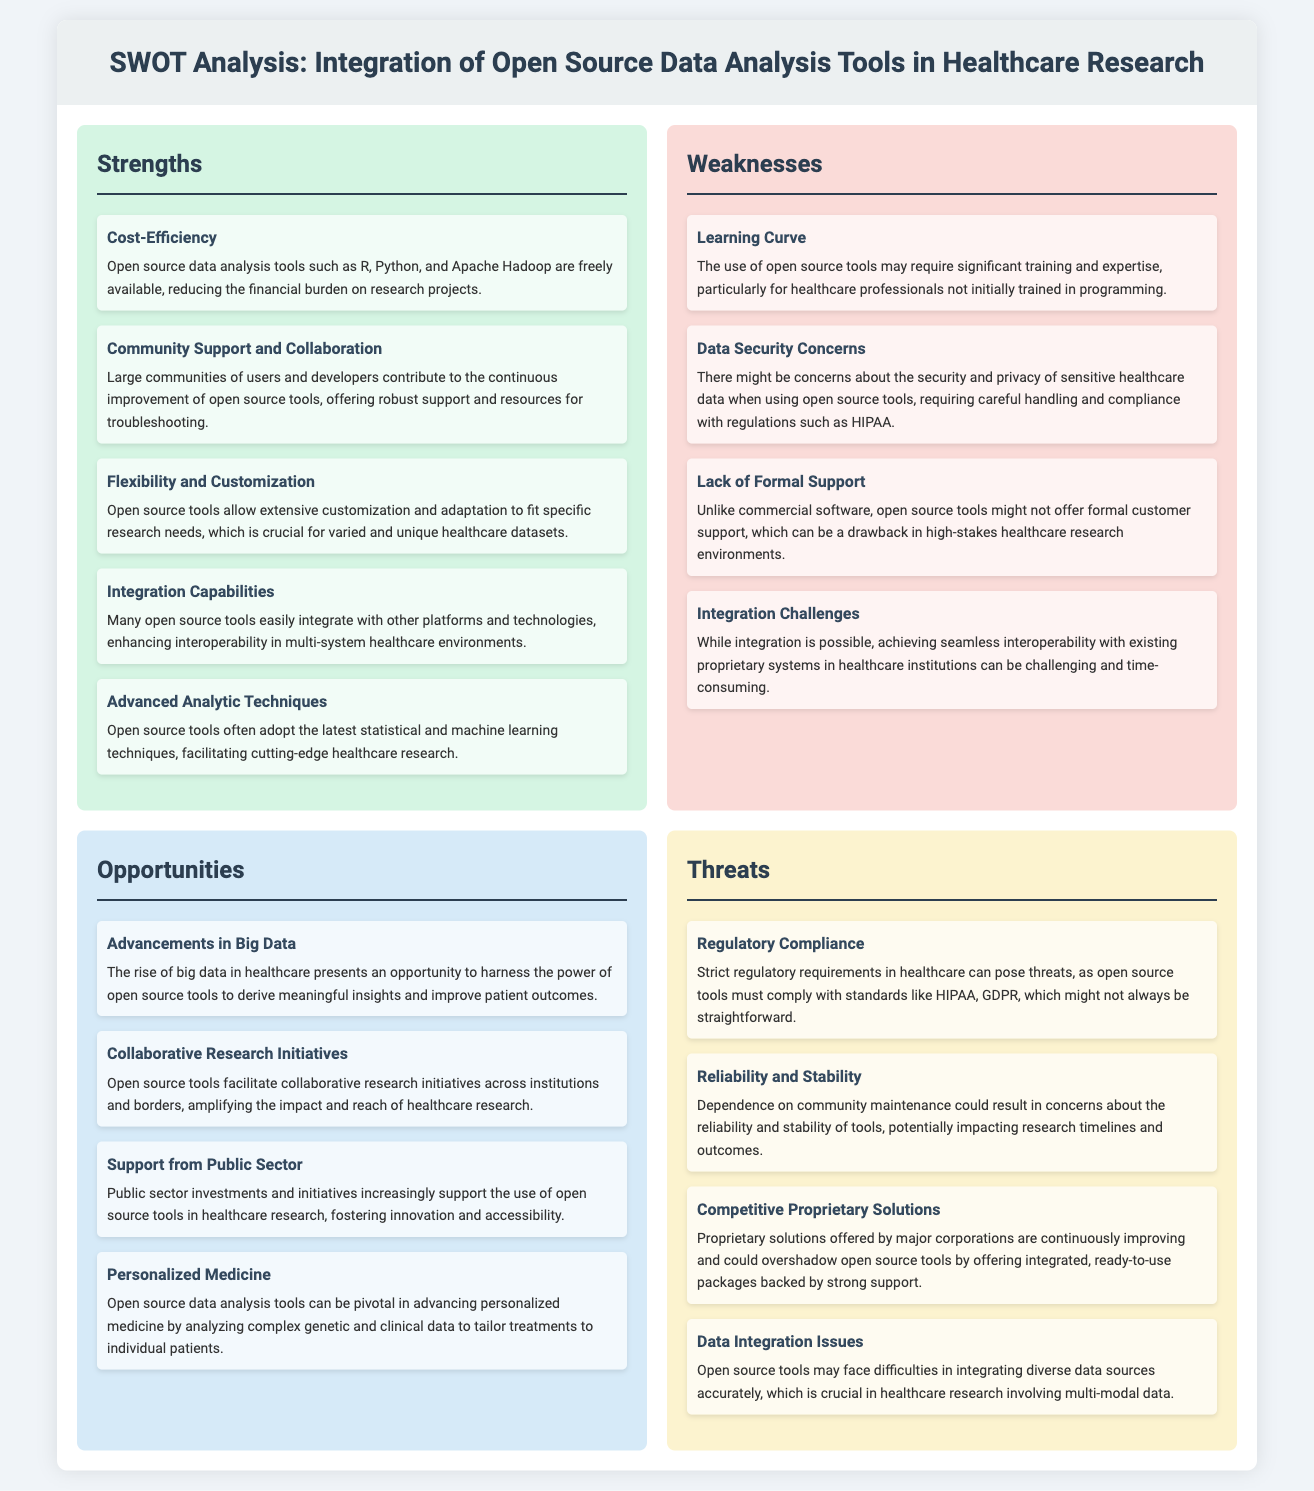what is a major strength of open source tools? The document states that one of the strengths is cost-efficiency, which highlights the financial advantages of using these tools in healthcare research.
Answer: cost-efficiency how many weaknesses are identified in the analysis? The analysis lists four distinct weaknesses that open source data analysis tools face in healthcare research.
Answer: four which opportunity relates to advancements in data? The document mentions that the rise of big data in healthcare provides an opportunity for researchers to utilize open source tools effectively.
Answer: advancements in big data name one threat that open source tools face in the healthcare sector. Among the threats stated, regulatory compliance is highlighted as a challenge that open source tools need to navigate.
Answer: regulatory compliance what type of support is mentioned as a strength of open source tools? The analysis indicates that community support and collaboration are critical strengths associated with the use of open source tools.
Answer: community support and collaboration which opportunity focuses on personalized treatment? The document notes that personalized medicine is an opportunity that open source tools can significantly advance through data analysis.
Answer: personalized medicine what is a challenge mentioned regarding formal support for open source tools? The document highlights that a lack of formal support is a weakness, which can impact usability in critical healthcare research environments.
Answer: lack of formal support what is one feature of open source tools that aids in interdisciplinary work? The analysis points out that integration capabilities are a strength that allows open source tools to work with various platforms and technologies.
Answer: integration capabilities 